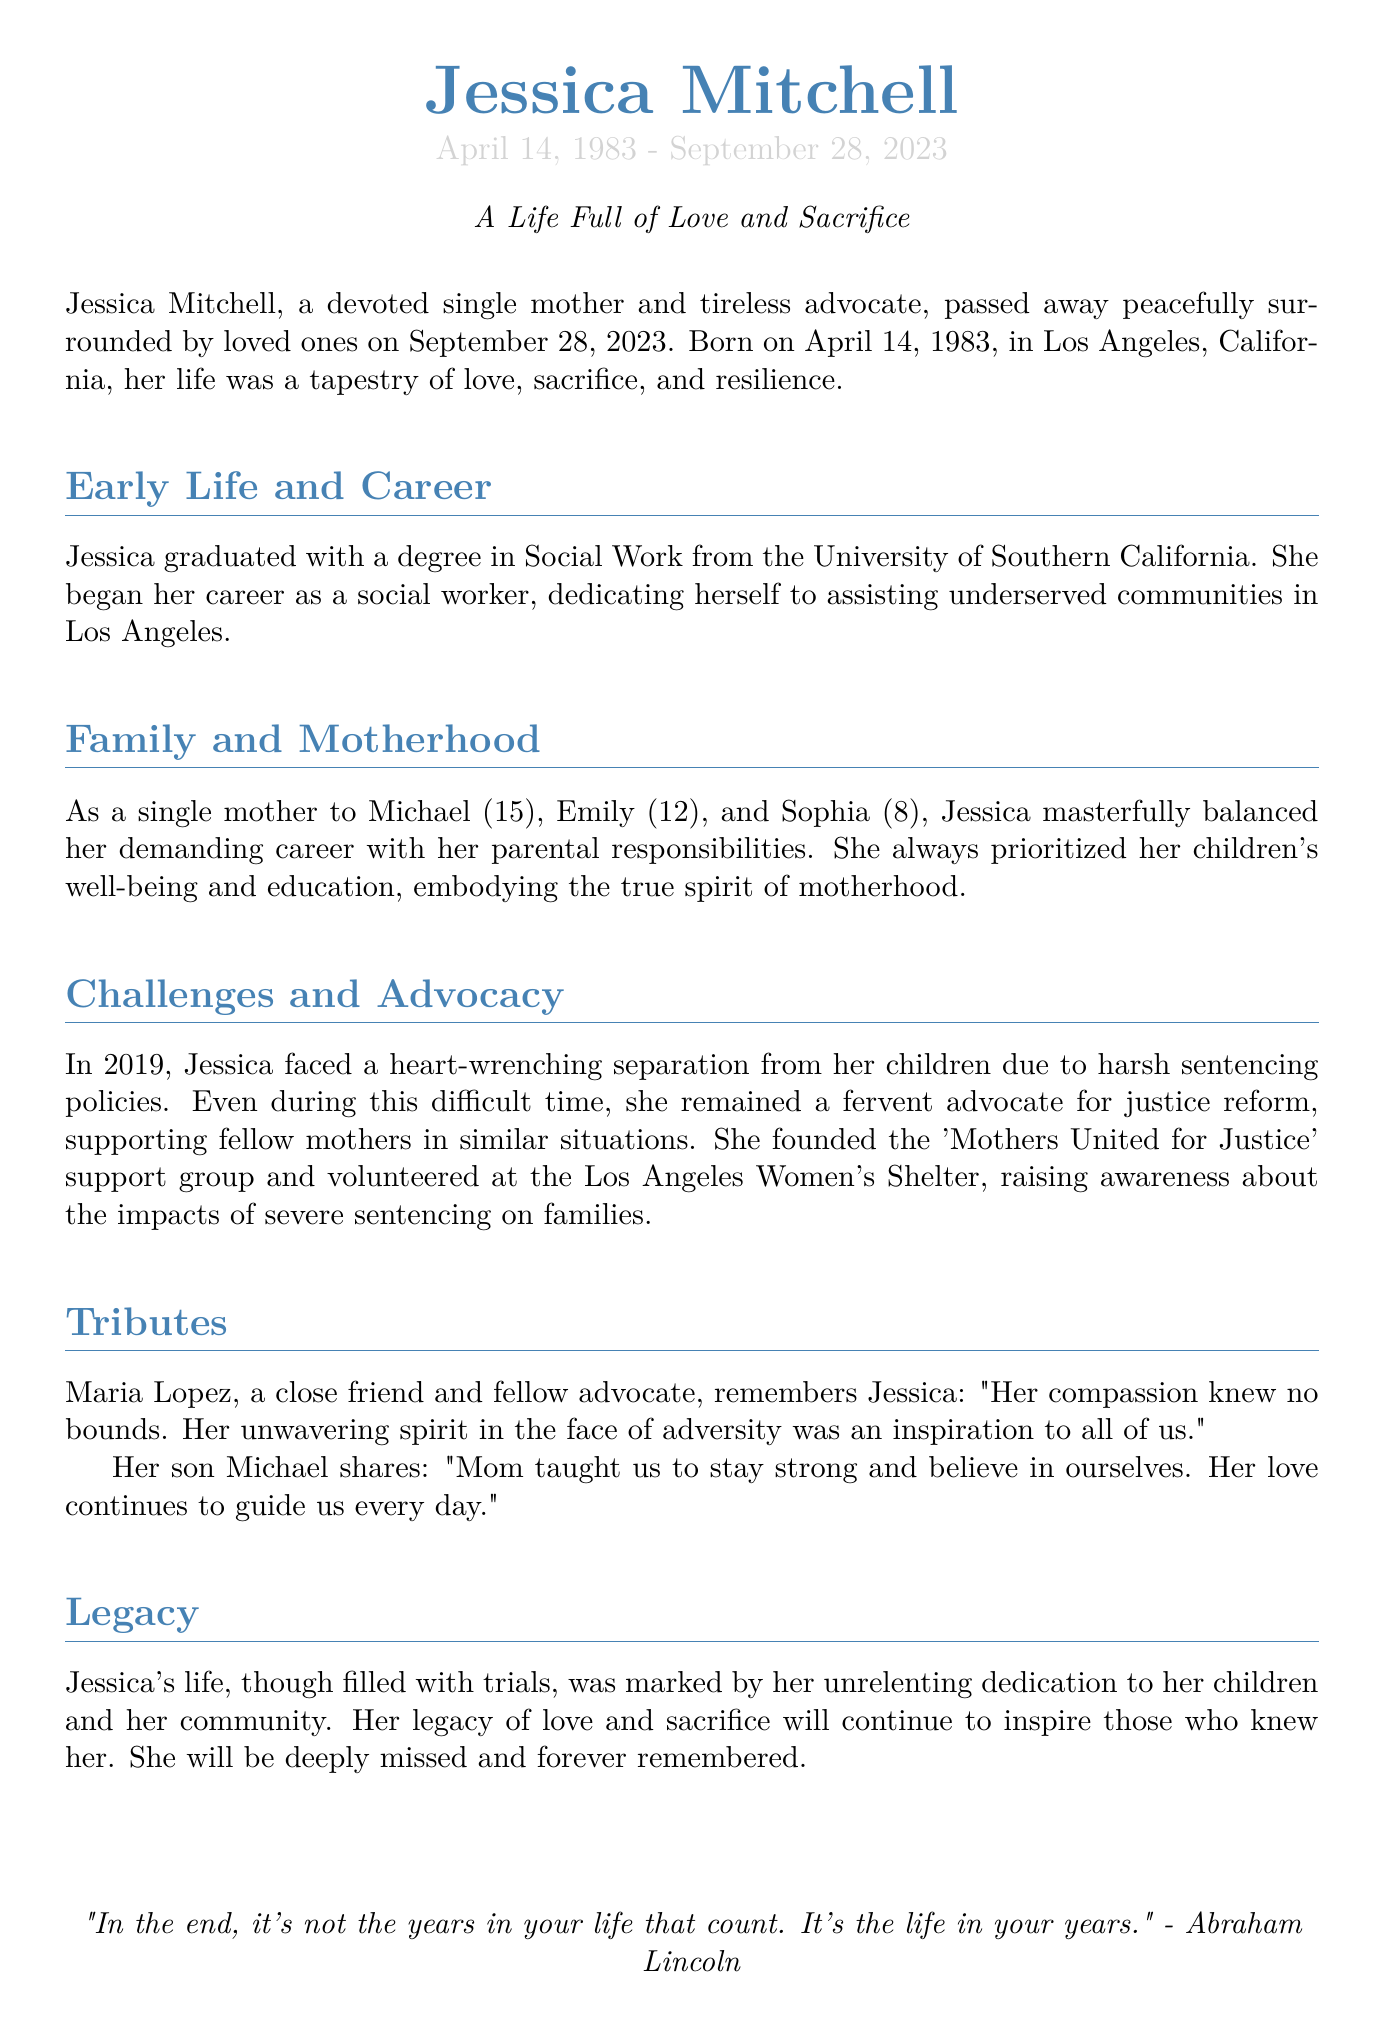What is Jessica Mitchell's birth date? Jessica Mitchell was born on April 14, 1983, as stated in the document.
Answer: April 14, 1983 In which city was Jessica born? The document mentions that Jessica was born in Los Angeles, California.
Answer: Los Angeles, California What degree did Jessica graduate with? Jessica graduated with a degree in Social Work, according to the document.
Answer: Social Work What year did Jessica face separation from her children? The document states that Jessica faced separation in 2019.
Answer: 2019 Who remembers Jessica as having boundless compassion? The document cites Maria Lopez as a close friend who remembers Jessica this way.
Answer: Maria Lopez What support group did Jessica found? Jessica founded the 'Mothers United for Justice' support group.
Answer: Mothers United for Justice How many children did Jessica have? Jessica is described as a single mother to three children.
Answer: three What is one way Jessica's legacy is described in the document? The document describes her legacy as marked by unrelenting dedication to her children and community.
Answer: unrelenting dedication What quote is included at the end of the document? The document includes a quote from Abraham Lincoln about life.
Answer: "In the end, it's not the years in your life that count. It's the life in your years." 